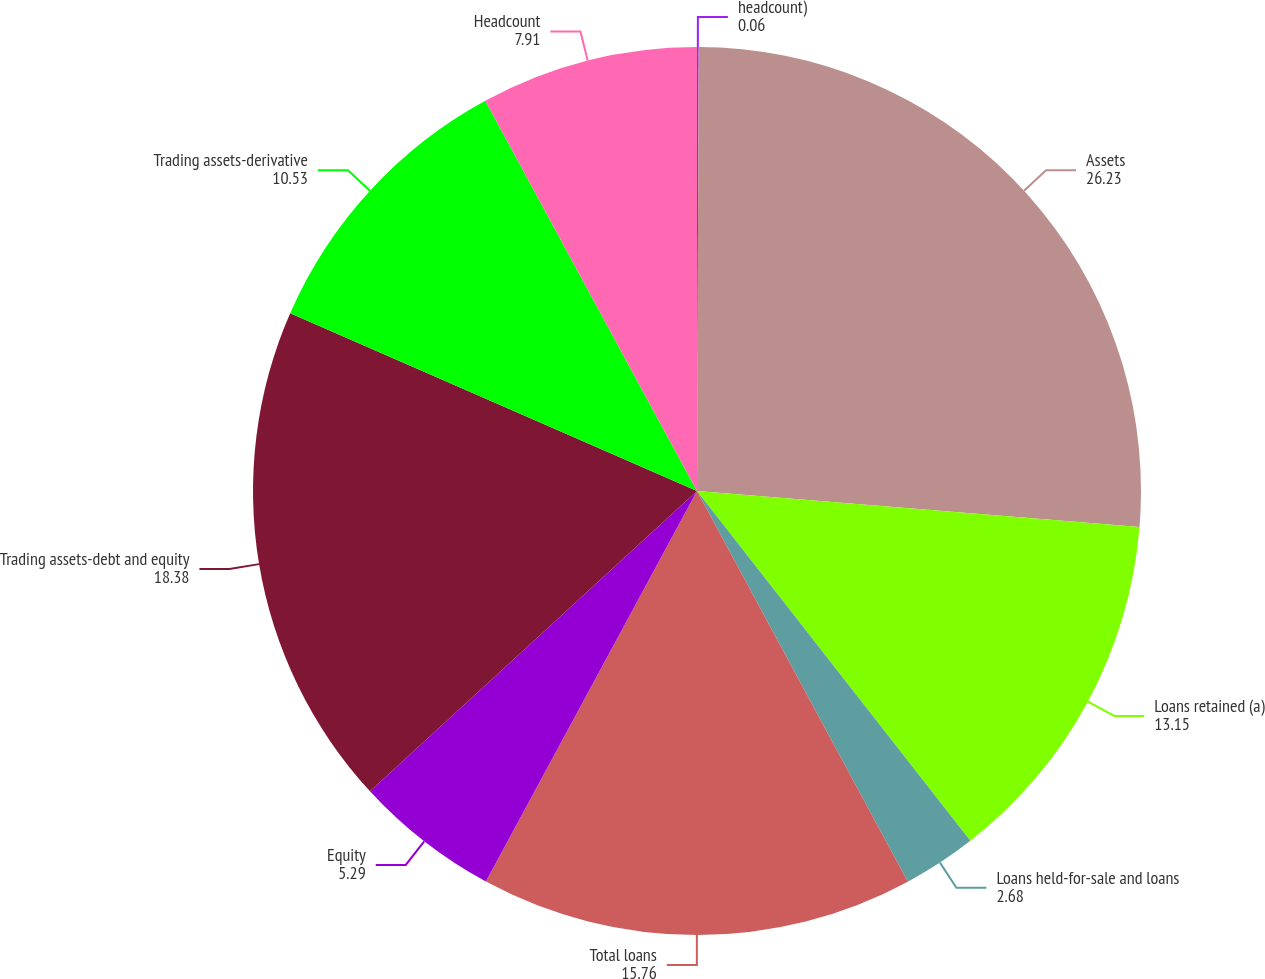Convert chart. <chart><loc_0><loc_0><loc_500><loc_500><pie_chart><fcel>headcount)<fcel>Assets<fcel>Loans retained (a)<fcel>Loans held-for-sale and loans<fcel>Total loans<fcel>Equity<fcel>Trading assets-debt and equity<fcel>Trading assets-derivative<fcel>Headcount<nl><fcel>0.06%<fcel>26.23%<fcel>13.15%<fcel>2.68%<fcel>15.76%<fcel>5.29%<fcel>18.38%<fcel>10.53%<fcel>7.91%<nl></chart> 